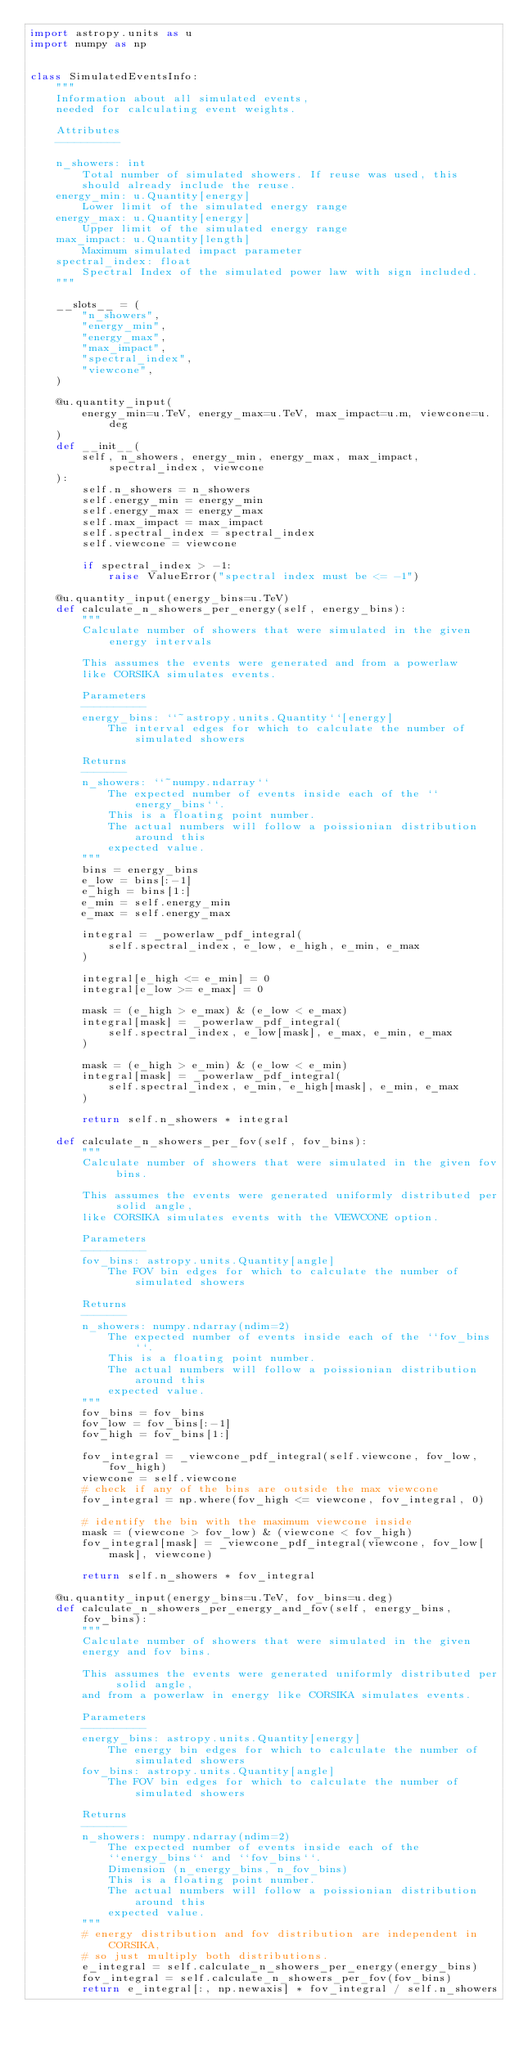<code> <loc_0><loc_0><loc_500><loc_500><_Python_>import astropy.units as u
import numpy as np


class SimulatedEventsInfo:
    """
    Information about all simulated events,
    needed for calculating event weights.

    Attributes
    ----------

    n_showers: int
        Total number of simulated showers. If reuse was used, this
        should already include the reuse.
    energy_min: u.Quantity[energy]
        Lower limit of the simulated energy range
    energy_max: u.Quantity[energy]
        Upper limit of the simulated energy range
    max_impact: u.Quantity[length]
        Maximum simulated impact parameter
    spectral_index: float
        Spectral Index of the simulated power law with sign included.
    """

    __slots__ = (
        "n_showers",
        "energy_min",
        "energy_max",
        "max_impact",
        "spectral_index",
        "viewcone",
    )

    @u.quantity_input(
        energy_min=u.TeV, energy_max=u.TeV, max_impact=u.m, viewcone=u.deg
    )
    def __init__(
        self, n_showers, energy_min, energy_max, max_impact, spectral_index, viewcone
    ):
        self.n_showers = n_showers
        self.energy_min = energy_min
        self.energy_max = energy_max
        self.max_impact = max_impact
        self.spectral_index = spectral_index
        self.viewcone = viewcone

        if spectral_index > -1:
            raise ValueError("spectral index must be <= -1")

    @u.quantity_input(energy_bins=u.TeV)
    def calculate_n_showers_per_energy(self, energy_bins):
        """
        Calculate number of showers that were simulated in the given energy intervals

        This assumes the events were generated and from a powerlaw
        like CORSIKA simulates events.

        Parameters
        ----------
        energy_bins: ``~astropy.units.Quantity``[energy]
            The interval edges for which to calculate the number of simulated showers

        Returns
        -------
        n_showers: ``~numpy.ndarray``
            The expected number of events inside each of the ``energy_bins``.
            This is a floating point number.
            The actual numbers will follow a poissionian distribution around this
            expected value.
        """
        bins = energy_bins
        e_low = bins[:-1]
        e_high = bins[1:]
        e_min = self.energy_min
        e_max = self.energy_max

        integral = _powerlaw_pdf_integral(
            self.spectral_index, e_low, e_high, e_min, e_max
        )

        integral[e_high <= e_min] = 0
        integral[e_low >= e_max] = 0

        mask = (e_high > e_max) & (e_low < e_max)
        integral[mask] = _powerlaw_pdf_integral(
            self.spectral_index, e_low[mask], e_max, e_min, e_max
        )

        mask = (e_high > e_min) & (e_low < e_min)
        integral[mask] = _powerlaw_pdf_integral(
            self.spectral_index, e_min, e_high[mask], e_min, e_max
        )

        return self.n_showers * integral

    def calculate_n_showers_per_fov(self, fov_bins):
        """
        Calculate number of showers that were simulated in the given fov bins.

        This assumes the events were generated uniformly distributed per solid angle,
        like CORSIKA simulates events with the VIEWCONE option.

        Parameters
        ----------
        fov_bins: astropy.units.Quantity[angle]
            The FOV bin edges for which to calculate the number of simulated showers

        Returns
        -------
        n_showers: numpy.ndarray(ndim=2)
            The expected number of events inside each of the ``fov_bins``.
            This is a floating point number.
            The actual numbers will follow a poissionian distribution around this
            expected value.
        """
        fov_bins = fov_bins
        fov_low = fov_bins[:-1]
        fov_high = fov_bins[1:]

        fov_integral = _viewcone_pdf_integral(self.viewcone, fov_low, fov_high)
        viewcone = self.viewcone
        # check if any of the bins are outside the max viewcone
        fov_integral = np.where(fov_high <= viewcone, fov_integral, 0)

        # identify the bin with the maximum viewcone inside
        mask = (viewcone > fov_low) & (viewcone < fov_high)
        fov_integral[mask] = _viewcone_pdf_integral(viewcone, fov_low[mask], viewcone)

        return self.n_showers * fov_integral

    @u.quantity_input(energy_bins=u.TeV, fov_bins=u.deg)
    def calculate_n_showers_per_energy_and_fov(self, energy_bins, fov_bins):
        """
        Calculate number of showers that were simulated in the given
        energy and fov bins.

        This assumes the events were generated uniformly distributed per solid angle,
        and from a powerlaw in energy like CORSIKA simulates events.

        Parameters
        ----------
        energy_bins: astropy.units.Quantity[energy]
            The energy bin edges for which to calculate the number of simulated showers
        fov_bins: astropy.units.Quantity[angle]
            The FOV bin edges for which to calculate the number of simulated showers

        Returns
        -------
        n_showers: numpy.ndarray(ndim=2)
            The expected number of events inside each of the
            ``energy_bins`` and ``fov_bins``.
            Dimension (n_energy_bins, n_fov_bins)
            This is a floating point number.
            The actual numbers will follow a poissionian distribution around this
            expected value.
        """
        # energy distribution and fov distribution are independent in CORSIKA,
        # so just multiply both distributions.
        e_integral = self.calculate_n_showers_per_energy(energy_bins)
        fov_integral = self.calculate_n_showers_per_fov(fov_bins)
        return e_integral[:, np.newaxis] * fov_integral / self.n_showers
</code> 